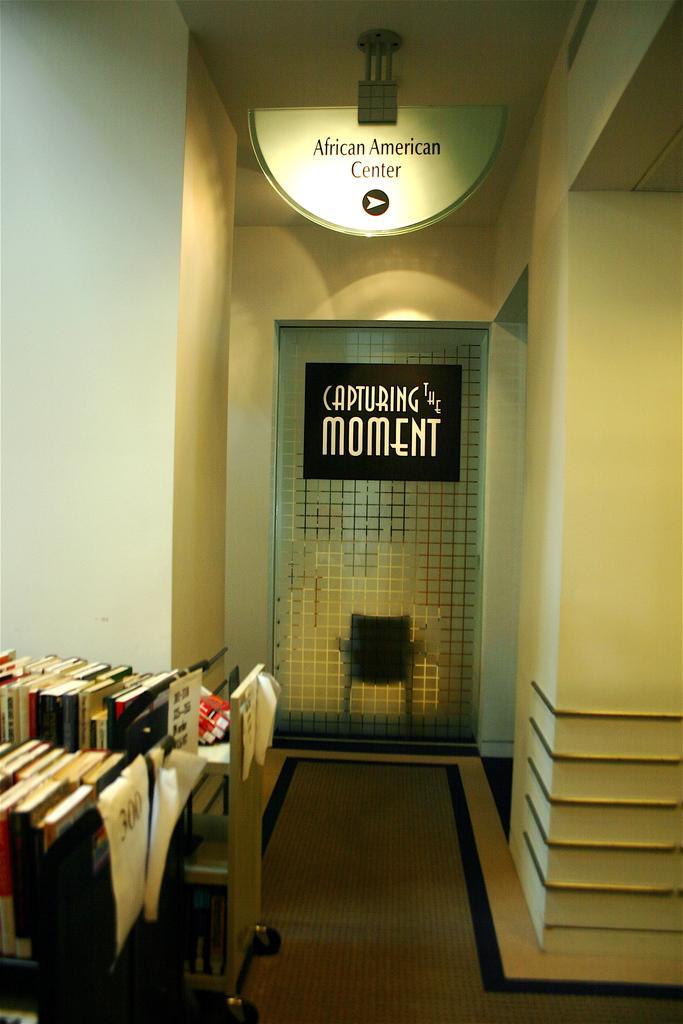How would you summarize this image in a sentence or two? As we can see in the image there is a wall, banner, chairs and table. On table there are books. 